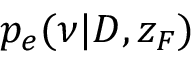Convert formula to latex. <formula><loc_0><loc_0><loc_500><loc_500>p _ { e } ( \nu | D , z _ { F } )</formula> 